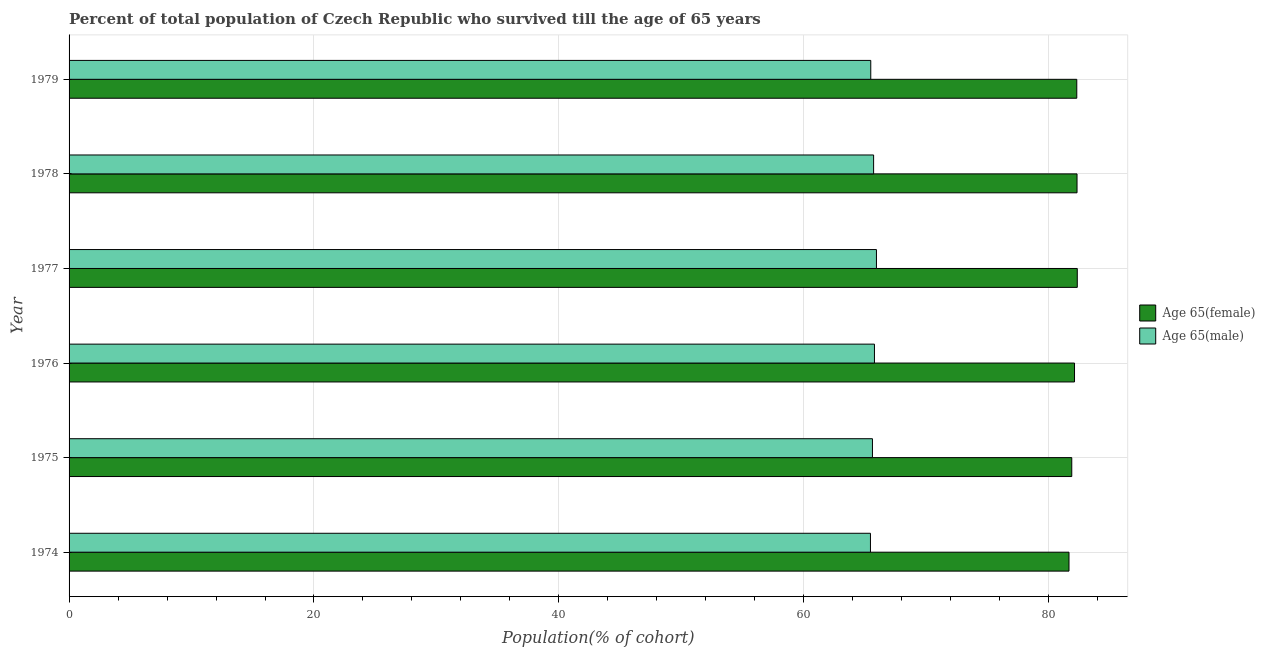How many different coloured bars are there?
Provide a short and direct response. 2. Are the number of bars on each tick of the Y-axis equal?
Ensure brevity in your answer.  Yes. What is the label of the 5th group of bars from the top?
Keep it short and to the point. 1975. In how many cases, is the number of bars for a given year not equal to the number of legend labels?
Your answer should be very brief. 0. What is the percentage of male population who survived till age of 65 in 1978?
Provide a succinct answer. 65.7. Across all years, what is the maximum percentage of female population who survived till age of 65?
Your answer should be compact. 82.33. Across all years, what is the minimum percentage of female population who survived till age of 65?
Provide a succinct answer. 81.66. In which year was the percentage of male population who survived till age of 65 minimum?
Keep it short and to the point. 1974. What is the total percentage of male population who survived till age of 65 in the graph?
Provide a succinct answer. 393.92. What is the difference between the percentage of male population who survived till age of 65 in 1974 and that in 1978?
Make the answer very short. -0.26. What is the difference between the percentage of female population who survived till age of 65 in 1979 and the percentage of male population who survived till age of 65 in 1977?
Offer a very short reply. 16.36. What is the average percentage of male population who survived till age of 65 per year?
Keep it short and to the point. 65.65. In the year 1974, what is the difference between the percentage of male population who survived till age of 65 and percentage of female population who survived till age of 65?
Give a very brief answer. -16.21. What is the ratio of the percentage of female population who survived till age of 65 in 1976 to that in 1978?
Ensure brevity in your answer.  1. Is the difference between the percentage of female population who survived till age of 65 in 1977 and 1979 greater than the difference between the percentage of male population who survived till age of 65 in 1977 and 1979?
Provide a short and direct response. No. What is the difference between the highest and the second highest percentage of male population who survived till age of 65?
Offer a very short reply. 0.16. What is the difference between the highest and the lowest percentage of female population who survived till age of 65?
Ensure brevity in your answer.  0.68. In how many years, is the percentage of male population who survived till age of 65 greater than the average percentage of male population who survived till age of 65 taken over all years?
Give a very brief answer. 3. Is the sum of the percentage of female population who survived till age of 65 in 1977 and 1978 greater than the maximum percentage of male population who survived till age of 65 across all years?
Your answer should be compact. Yes. What does the 1st bar from the top in 1977 represents?
Offer a terse response. Age 65(male). What does the 2nd bar from the bottom in 1976 represents?
Offer a very short reply. Age 65(male). How many bars are there?
Provide a succinct answer. 12. Are all the bars in the graph horizontal?
Provide a short and direct response. Yes. What is the difference between two consecutive major ticks on the X-axis?
Offer a terse response. 20. Are the values on the major ticks of X-axis written in scientific E-notation?
Your answer should be compact. No. How many legend labels are there?
Your answer should be compact. 2. What is the title of the graph?
Give a very brief answer. Percent of total population of Czech Republic who survived till the age of 65 years. What is the label or title of the X-axis?
Offer a very short reply. Population(% of cohort). What is the Population(% of cohort) in Age 65(female) in 1974?
Provide a short and direct response. 81.66. What is the Population(% of cohort) in Age 65(male) in 1974?
Keep it short and to the point. 65.44. What is the Population(% of cohort) of Age 65(female) in 1975?
Provide a short and direct response. 81.88. What is the Population(% of cohort) of Age 65(male) in 1975?
Ensure brevity in your answer.  65.61. What is the Population(% of cohort) of Age 65(female) in 1976?
Ensure brevity in your answer.  82.11. What is the Population(% of cohort) of Age 65(male) in 1976?
Offer a terse response. 65.77. What is the Population(% of cohort) in Age 65(female) in 1977?
Offer a very short reply. 82.33. What is the Population(% of cohort) of Age 65(male) in 1977?
Keep it short and to the point. 65.93. What is the Population(% of cohort) of Age 65(female) in 1978?
Your response must be concise. 82.31. What is the Population(% of cohort) of Age 65(male) in 1978?
Make the answer very short. 65.7. What is the Population(% of cohort) of Age 65(female) in 1979?
Your response must be concise. 82.29. What is the Population(% of cohort) of Age 65(male) in 1979?
Ensure brevity in your answer.  65.47. Across all years, what is the maximum Population(% of cohort) in Age 65(female)?
Provide a short and direct response. 82.33. Across all years, what is the maximum Population(% of cohort) in Age 65(male)?
Ensure brevity in your answer.  65.93. Across all years, what is the minimum Population(% of cohort) of Age 65(female)?
Make the answer very short. 81.66. Across all years, what is the minimum Population(% of cohort) in Age 65(male)?
Provide a short and direct response. 65.44. What is the total Population(% of cohort) of Age 65(female) in the graph?
Keep it short and to the point. 492.59. What is the total Population(% of cohort) of Age 65(male) in the graph?
Provide a succinct answer. 393.92. What is the difference between the Population(% of cohort) of Age 65(female) in 1974 and that in 1975?
Give a very brief answer. -0.23. What is the difference between the Population(% of cohort) of Age 65(male) in 1974 and that in 1975?
Give a very brief answer. -0.16. What is the difference between the Population(% of cohort) in Age 65(female) in 1974 and that in 1976?
Provide a succinct answer. -0.45. What is the difference between the Population(% of cohort) of Age 65(male) in 1974 and that in 1976?
Your response must be concise. -0.33. What is the difference between the Population(% of cohort) in Age 65(female) in 1974 and that in 1977?
Give a very brief answer. -0.68. What is the difference between the Population(% of cohort) in Age 65(male) in 1974 and that in 1977?
Keep it short and to the point. -0.49. What is the difference between the Population(% of cohort) in Age 65(female) in 1974 and that in 1978?
Keep it short and to the point. -0.66. What is the difference between the Population(% of cohort) in Age 65(male) in 1974 and that in 1978?
Keep it short and to the point. -0.26. What is the difference between the Population(% of cohort) of Age 65(female) in 1974 and that in 1979?
Make the answer very short. -0.64. What is the difference between the Population(% of cohort) of Age 65(male) in 1974 and that in 1979?
Make the answer very short. -0.03. What is the difference between the Population(% of cohort) of Age 65(female) in 1975 and that in 1976?
Offer a terse response. -0.23. What is the difference between the Population(% of cohort) of Age 65(male) in 1975 and that in 1976?
Offer a very short reply. -0.16. What is the difference between the Population(% of cohort) in Age 65(female) in 1975 and that in 1977?
Provide a short and direct response. -0.45. What is the difference between the Population(% of cohort) of Age 65(male) in 1975 and that in 1977?
Your answer should be very brief. -0.33. What is the difference between the Population(% of cohort) in Age 65(female) in 1975 and that in 1978?
Ensure brevity in your answer.  -0.43. What is the difference between the Population(% of cohort) in Age 65(male) in 1975 and that in 1978?
Give a very brief answer. -0.1. What is the difference between the Population(% of cohort) of Age 65(female) in 1975 and that in 1979?
Your answer should be very brief. -0.41. What is the difference between the Population(% of cohort) in Age 65(male) in 1975 and that in 1979?
Ensure brevity in your answer.  0.14. What is the difference between the Population(% of cohort) in Age 65(female) in 1976 and that in 1977?
Provide a short and direct response. -0.23. What is the difference between the Population(% of cohort) of Age 65(male) in 1976 and that in 1977?
Ensure brevity in your answer.  -0.16. What is the difference between the Population(% of cohort) of Age 65(female) in 1976 and that in 1978?
Your answer should be very brief. -0.21. What is the difference between the Population(% of cohort) in Age 65(male) in 1976 and that in 1978?
Your answer should be compact. 0.07. What is the difference between the Population(% of cohort) in Age 65(female) in 1976 and that in 1979?
Your answer should be compact. -0.18. What is the difference between the Population(% of cohort) in Age 65(male) in 1976 and that in 1979?
Ensure brevity in your answer.  0.3. What is the difference between the Population(% of cohort) of Age 65(female) in 1977 and that in 1978?
Your answer should be compact. 0.02. What is the difference between the Population(% of cohort) in Age 65(male) in 1977 and that in 1978?
Offer a very short reply. 0.23. What is the difference between the Population(% of cohort) in Age 65(female) in 1977 and that in 1979?
Give a very brief answer. 0.04. What is the difference between the Population(% of cohort) of Age 65(male) in 1977 and that in 1979?
Your answer should be very brief. 0.46. What is the difference between the Population(% of cohort) in Age 65(female) in 1978 and that in 1979?
Your response must be concise. 0.02. What is the difference between the Population(% of cohort) of Age 65(male) in 1978 and that in 1979?
Your answer should be very brief. 0.23. What is the difference between the Population(% of cohort) of Age 65(female) in 1974 and the Population(% of cohort) of Age 65(male) in 1975?
Your answer should be compact. 16.05. What is the difference between the Population(% of cohort) of Age 65(female) in 1974 and the Population(% of cohort) of Age 65(male) in 1976?
Give a very brief answer. 15.89. What is the difference between the Population(% of cohort) of Age 65(female) in 1974 and the Population(% of cohort) of Age 65(male) in 1977?
Provide a short and direct response. 15.72. What is the difference between the Population(% of cohort) in Age 65(female) in 1974 and the Population(% of cohort) in Age 65(male) in 1978?
Your answer should be very brief. 15.96. What is the difference between the Population(% of cohort) in Age 65(female) in 1974 and the Population(% of cohort) in Age 65(male) in 1979?
Offer a very short reply. 16.19. What is the difference between the Population(% of cohort) in Age 65(female) in 1975 and the Population(% of cohort) in Age 65(male) in 1976?
Your answer should be compact. 16.11. What is the difference between the Population(% of cohort) of Age 65(female) in 1975 and the Population(% of cohort) of Age 65(male) in 1977?
Your response must be concise. 15.95. What is the difference between the Population(% of cohort) in Age 65(female) in 1975 and the Population(% of cohort) in Age 65(male) in 1978?
Offer a very short reply. 16.18. What is the difference between the Population(% of cohort) of Age 65(female) in 1975 and the Population(% of cohort) of Age 65(male) in 1979?
Provide a succinct answer. 16.41. What is the difference between the Population(% of cohort) in Age 65(female) in 1976 and the Population(% of cohort) in Age 65(male) in 1977?
Give a very brief answer. 16.17. What is the difference between the Population(% of cohort) of Age 65(female) in 1976 and the Population(% of cohort) of Age 65(male) in 1978?
Your answer should be very brief. 16.41. What is the difference between the Population(% of cohort) in Age 65(female) in 1976 and the Population(% of cohort) in Age 65(male) in 1979?
Your response must be concise. 16.64. What is the difference between the Population(% of cohort) of Age 65(female) in 1977 and the Population(% of cohort) of Age 65(male) in 1978?
Make the answer very short. 16.63. What is the difference between the Population(% of cohort) in Age 65(female) in 1977 and the Population(% of cohort) in Age 65(male) in 1979?
Keep it short and to the point. 16.86. What is the difference between the Population(% of cohort) in Age 65(female) in 1978 and the Population(% of cohort) in Age 65(male) in 1979?
Your response must be concise. 16.84. What is the average Population(% of cohort) in Age 65(female) per year?
Make the answer very short. 82.1. What is the average Population(% of cohort) in Age 65(male) per year?
Ensure brevity in your answer.  65.65. In the year 1974, what is the difference between the Population(% of cohort) of Age 65(female) and Population(% of cohort) of Age 65(male)?
Give a very brief answer. 16.21. In the year 1975, what is the difference between the Population(% of cohort) of Age 65(female) and Population(% of cohort) of Age 65(male)?
Offer a very short reply. 16.28. In the year 1976, what is the difference between the Population(% of cohort) of Age 65(female) and Population(% of cohort) of Age 65(male)?
Provide a succinct answer. 16.34. In the year 1977, what is the difference between the Population(% of cohort) in Age 65(female) and Population(% of cohort) in Age 65(male)?
Offer a terse response. 16.4. In the year 1978, what is the difference between the Population(% of cohort) of Age 65(female) and Population(% of cohort) of Age 65(male)?
Provide a short and direct response. 16.61. In the year 1979, what is the difference between the Population(% of cohort) in Age 65(female) and Population(% of cohort) in Age 65(male)?
Offer a very short reply. 16.82. What is the ratio of the Population(% of cohort) in Age 65(female) in 1974 to that in 1975?
Provide a succinct answer. 1. What is the ratio of the Population(% of cohort) in Age 65(male) in 1974 to that in 1976?
Give a very brief answer. 0.99. What is the ratio of the Population(% of cohort) of Age 65(male) in 1974 to that in 1977?
Your answer should be compact. 0.99. What is the ratio of the Population(% of cohort) of Age 65(male) in 1974 to that in 1978?
Provide a short and direct response. 1. What is the ratio of the Population(% of cohort) in Age 65(male) in 1974 to that in 1979?
Provide a short and direct response. 1. What is the ratio of the Population(% of cohort) in Age 65(female) in 1975 to that in 1976?
Provide a short and direct response. 1. What is the ratio of the Population(% of cohort) in Age 65(female) in 1975 to that in 1977?
Your answer should be compact. 0.99. What is the ratio of the Population(% of cohort) of Age 65(female) in 1975 to that in 1978?
Your answer should be compact. 0.99. What is the ratio of the Population(% of cohort) of Age 65(male) in 1975 to that in 1978?
Offer a terse response. 1. What is the ratio of the Population(% of cohort) in Age 65(female) in 1975 to that in 1979?
Make the answer very short. 0.99. What is the ratio of the Population(% of cohort) of Age 65(male) in 1975 to that in 1979?
Your answer should be very brief. 1. What is the ratio of the Population(% of cohort) in Age 65(male) in 1976 to that in 1977?
Your response must be concise. 1. What is the ratio of the Population(% of cohort) in Age 65(female) in 1976 to that in 1978?
Your answer should be compact. 1. What is the ratio of the Population(% of cohort) of Age 65(male) in 1976 to that in 1978?
Ensure brevity in your answer.  1. What is the ratio of the Population(% of cohort) in Age 65(female) in 1976 to that in 1979?
Offer a terse response. 1. What is the ratio of the Population(% of cohort) of Age 65(male) in 1976 to that in 1979?
Make the answer very short. 1. What is the ratio of the Population(% of cohort) of Age 65(female) in 1977 to that in 1978?
Provide a succinct answer. 1. What is the ratio of the Population(% of cohort) in Age 65(female) in 1977 to that in 1979?
Provide a short and direct response. 1. What is the ratio of the Population(% of cohort) in Age 65(male) in 1977 to that in 1979?
Your answer should be compact. 1.01. What is the ratio of the Population(% of cohort) in Age 65(female) in 1978 to that in 1979?
Provide a succinct answer. 1. What is the difference between the highest and the second highest Population(% of cohort) in Age 65(female)?
Offer a terse response. 0.02. What is the difference between the highest and the second highest Population(% of cohort) in Age 65(male)?
Ensure brevity in your answer.  0.16. What is the difference between the highest and the lowest Population(% of cohort) of Age 65(female)?
Your answer should be very brief. 0.68. What is the difference between the highest and the lowest Population(% of cohort) of Age 65(male)?
Your answer should be compact. 0.49. 